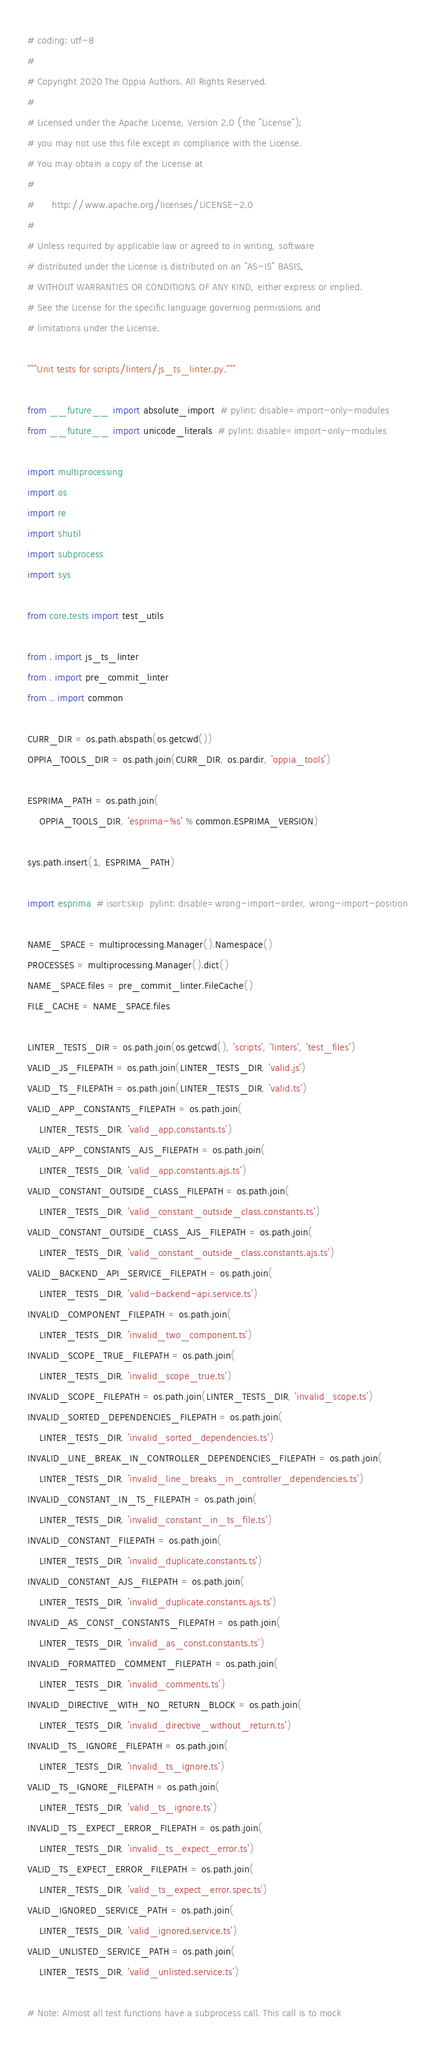<code> <loc_0><loc_0><loc_500><loc_500><_Python_># coding: utf-8
#
# Copyright 2020 The Oppia Authors. All Rights Reserved.
#
# Licensed under the Apache License, Version 2.0 (the "License");
# you may not use this file except in compliance with the License.
# You may obtain a copy of the License at
#
#      http://www.apache.org/licenses/LICENSE-2.0
#
# Unless required by applicable law or agreed to in writing, software
# distributed under the License is distributed on an "AS-IS" BASIS,
# WITHOUT WARRANTIES OR CONDITIONS OF ANY KIND, either express or implied.
# See the License for the specific language governing permissions and
# limitations under the License.

"""Unit tests for scripts/linters/js_ts_linter.py."""

from __future__ import absolute_import  # pylint: disable=import-only-modules
from __future__ import unicode_literals  # pylint: disable=import-only-modules

import multiprocessing
import os
import re
import shutil
import subprocess
import sys

from core.tests import test_utils

from . import js_ts_linter
from . import pre_commit_linter
from .. import common

CURR_DIR = os.path.abspath(os.getcwd())
OPPIA_TOOLS_DIR = os.path.join(CURR_DIR, os.pardir, 'oppia_tools')

ESPRIMA_PATH = os.path.join(
    OPPIA_TOOLS_DIR, 'esprima-%s' % common.ESPRIMA_VERSION)

sys.path.insert(1, ESPRIMA_PATH)

import esprima  # isort:skip  pylint: disable=wrong-import-order, wrong-import-position

NAME_SPACE = multiprocessing.Manager().Namespace()
PROCESSES = multiprocessing.Manager().dict()
NAME_SPACE.files = pre_commit_linter.FileCache()
FILE_CACHE = NAME_SPACE.files

LINTER_TESTS_DIR = os.path.join(os.getcwd(), 'scripts', 'linters', 'test_files')
VALID_JS_FILEPATH = os.path.join(LINTER_TESTS_DIR, 'valid.js')
VALID_TS_FILEPATH = os.path.join(LINTER_TESTS_DIR, 'valid.ts')
VALID_APP_CONSTANTS_FILEPATH = os.path.join(
    LINTER_TESTS_DIR, 'valid_app.constants.ts')
VALID_APP_CONSTANTS_AJS_FILEPATH = os.path.join(
    LINTER_TESTS_DIR, 'valid_app.constants.ajs.ts')
VALID_CONSTANT_OUTSIDE_CLASS_FILEPATH = os.path.join(
    LINTER_TESTS_DIR, 'valid_constant_outside_class.constants.ts')
VALID_CONSTANT_OUTSIDE_CLASS_AJS_FILEPATH = os.path.join(
    LINTER_TESTS_DIR, 'valid_constant_outside_class.constants.ajs.ts')
VALID_BACKEND_API_SERVICE_FILEPATH = os.path.join(
    LINTER_TESTS_DIR, 'valid-backend-api.service.ts')
INVALID_COMPONENT_FILEPATH = os.path.join(
    LINTER_TESTS_DIR, 'invalid_two_component.ts')
INVALID_SCOPE_TRUE_FILEPATH = os.path.join(
    LINTER_TESTS_DIR, 'invalid_scope_true.ts')
INVALID_SCOPE_FILEPATH = os.path.join(LINTER_TESTS_DIR, 'invalid_scope.ts')
INVALID_SORTED_DEPENDENCIES_FILEPATH = os.path.join(
    LINTER_TESTS_DIR, 'invalid_sorted_dependencies.ts')
INVALID_LINE_BREAK_IN_CONTROLLER_DEPENDENCIES_FILEPATH = os.path.join(
    LINTER_TESTS_DIR, 'invalid_line_breaks_in_controller_dependencies.ts')
INVALID_CONSTANT_IN_TS_FILEPATH = os.path.join(
    LINTER_TESTS_DIR, 'invalid_constant_in_ts_file.ts')
INVALID_CONSTANT_FILEPATH = os.path.join(
    LINTER_TESTS_DIR, 'invalid_duplicate.constants.ts')
INVALID_CONSTANT_AJS_FILEPATH = os.path.join(
    LINTER_TESTS_DIR, 'invalid_duplicate.constants.ajs.ts')
INVALID_AS_CONST_CONSTANTS_FILEPATH = os.path.join(
    LINTER_TESTS_DIR, 'invalid_as_const.constants.ts')
INVALID_FORMATTED_COMMENT_FILEPATH = os.path.join(
    LINTER_TESTS_DIR, 'invalid_comments.ts')
INVALID_DIRECTIVE_WITH_NO_RETURN_BLOCK = os.path.join(
    LINTER_TESTS_DIR, 'invalid_directive_without_return.ts')
INVALID_TS_IGNORE_FILEPATH = os.path.join(
    LINTER_TESTS_DIR, 'invalid_ts_ignore.ts')
VALID_TS_IGNORE_FILEPATH = os.path.join(
    LINTER_TESTS_DIR, 'valid_ts_ignore.ts')
INVALID_TS_EXPECT_ERROR_FILEPATH = os.path.join(
    LINTER_TESTS_DIR, 'invalid_ts_expect_error.ts')
VALID_TS_EXPECT_ERROR_FILEPATH = os.path.join(
    LINTER_TESTS_DIR, 'valid_ts_expect_error.spec.ts')
VALID_IGNORED_SERVICE_PATH = os.path.join(
    LINTER_TESTS_DIR, 'valid_ignored.service.ts')
VALID_UNLISTED_SERVICE_PATH = os.path.join(
    LINTER_TESTS_DIR, 'valid_unlisted.service.ts')

# Note: Almost all test functions have a subprocess call. This call is to mock</code> 